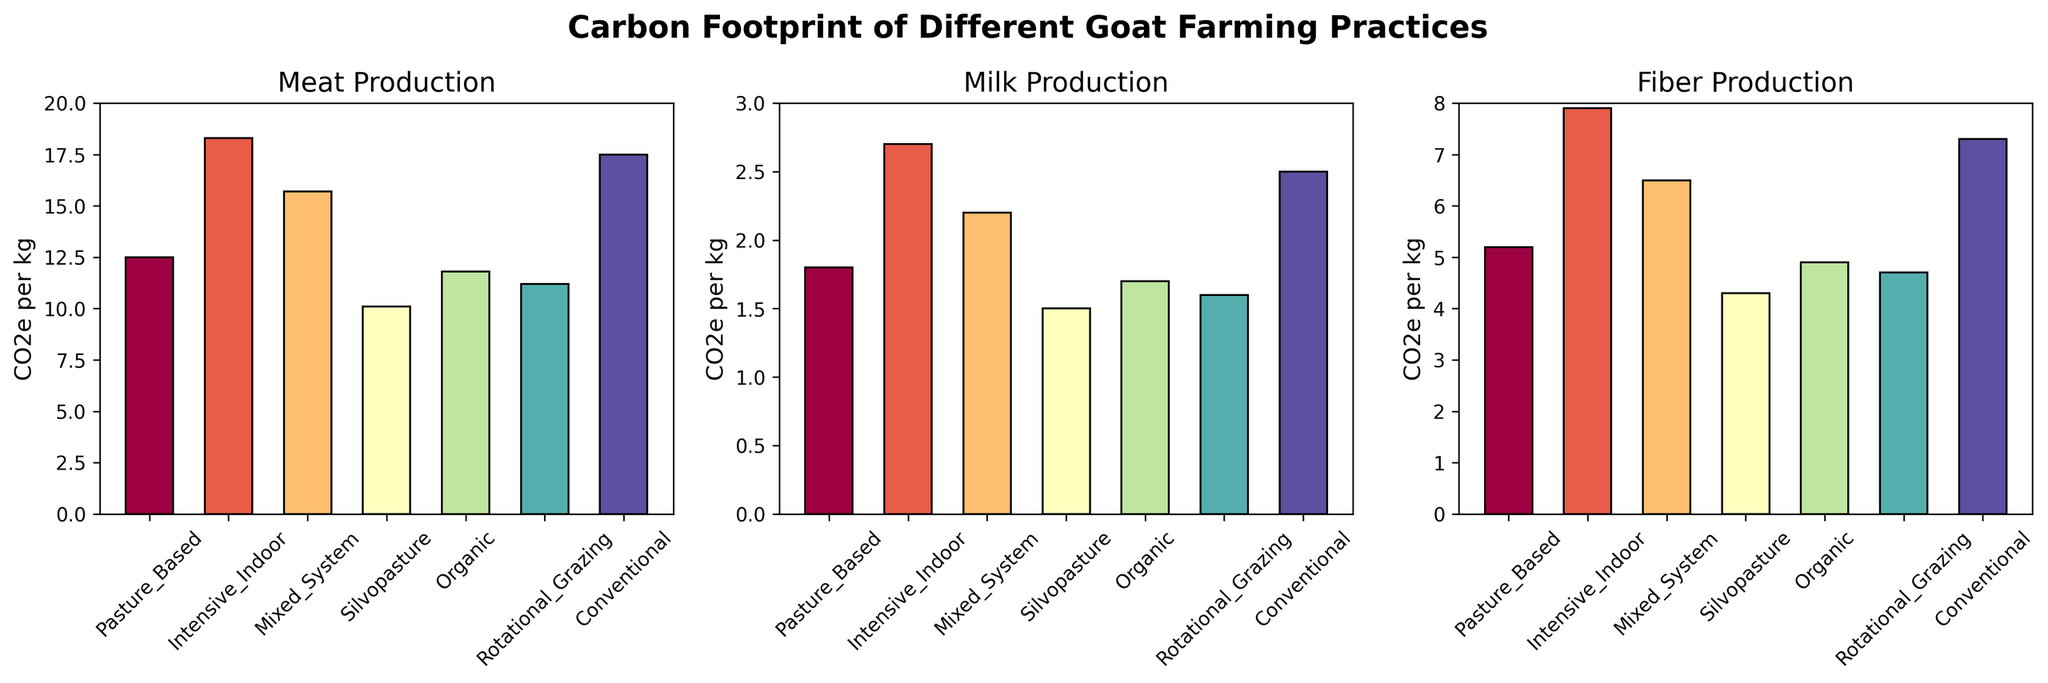What's the total CO2 equivalent per kg for Meat Production in all farming practices? Add all values for Meat Production (12.5 + 18.3 + 15.7 + 10.1 + 11.8 + 11.2 + 17.5). This equals 97.1.
Answer: 97.1 Which farming practice has the lowest CO2e per kg for Milk Production? By inspecting the Milk Production subplot, Silvopasture has the lowest bar, indicating the lowest CO2e per kg at 1.5.
Answer: Silvopasture How does the CO2e per kg for Meat Production in Pasture-Based compare with that in Intensive Indoor? The Meat CO2e per kg for Pasture-Based is 12.5 and for Intensive Indoor is 18.3. Pasture-Based is lower than Intensive Indoor.
Answer: Pasture-Based is lower What is the difference in CO2e per kg for Fiber Production between Mixed System and Rotational Grazing? The CO2e per kg for Fiber Production in Mixed System is 6.5 and for Rotational Grazing is 4.7. The difference is 6.5 - 4.7 = 1.8.
Answer: 1.8 Which farming practice shows the highest CO2e per kg for Meat Production? In the Meat Production subplot, Intensive Indoor shows the highest bar with a value of 18.3 CO2e per kg.
Answer: Intensive Indoor What's the average CO2e per kg for Milk Production across all farming practices? The values are 1.8, 2.7, 2.2, 1.5, 1.7, 1.6, 2.5 for each practice. Summing these gives 14, and the average is 14 / 7 = 2.
Answer: 2 If you were to adopt a sustainable practice, which farming system would you consider for minimizing CO2 emission per kg for Milk and Fiber production? Silvopasture shows the lowest CO2e per kg for both Milk (1.5) and Fiber (4.3) among all practices on the subplots.
Answer: Silvopasture What are the CO2e per kg for Meat, Milk, and Fiber production in the Organic farming practice? Look at the respective bar heights for Meat (11.8), Milk (1.7), and Fiber (4.9) in the respective subplots for Organic farming.
Answer: 11.8, 1.7, 4.9 Which farming practices seem to have closer CO2e per kg values for Meat and Fiber production, and what are the values? Pasture-Based has 12.5 for Meat and 5.2 for Fiber, while Mixed System has 15.7 for Meat and 6.5 for Fiber. These are somewhat close in magnitude, but looking closer, Pasture-Based values are closer in terms of their ratio.
Answer: Pasture-Based, 12.5 and 5.2 What is the percentage difference in CO2e per kg for Fiber Production between Conventional and Rotational Grazing practices? The CO2e for Conventional is 7.3, and for Rotational Grazing is 4.7. The difference is 7.3 - 4.7 = 2.6. The percentage difference is 2.6 / 7.3 * 100%, which is approximately 35.6%.
Answer: 35.6% 